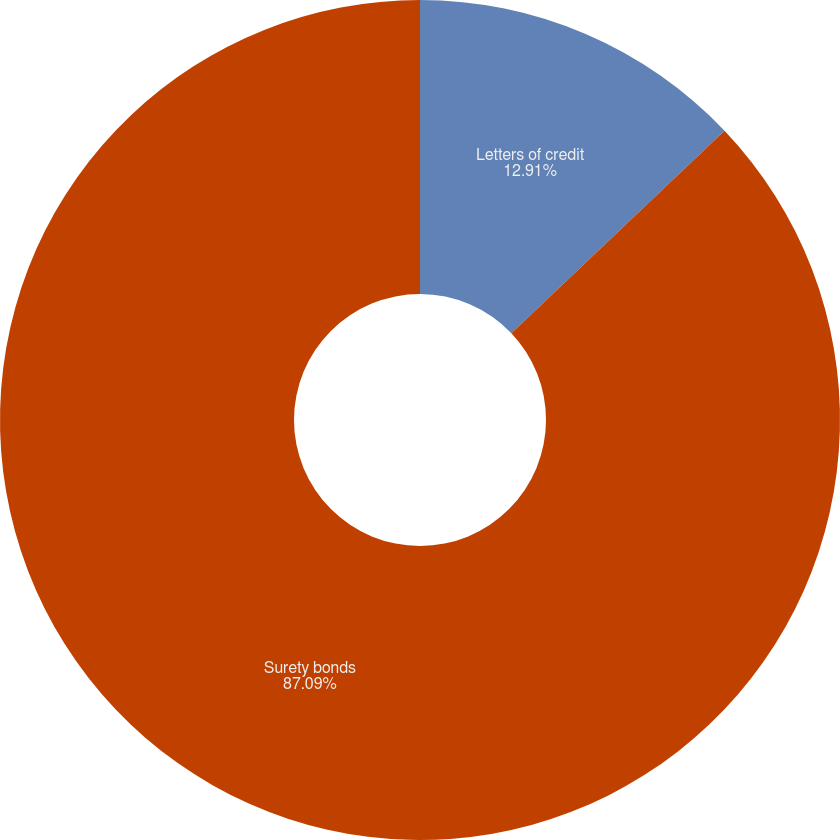<chart> <loc_0><loc_0><loc_500><loc_500><pie_chart><fcel>Letters of credit<fcel>Surety bonds<nl><fcel>12.91%<fcel>87.09%<nl></chart> 